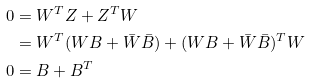<formula> <loc_0><loc_0><loc_500><loc_500>0 & = W ^ { T } Z + Z ^ { T } W \\ & = W ^ { T } ( W B + \bar { W } \bar { B } ) + ( W B + \bar { W } \bar { B } ) ^ { T } W \\ 0 & = B + B ^ { T }</formula> 